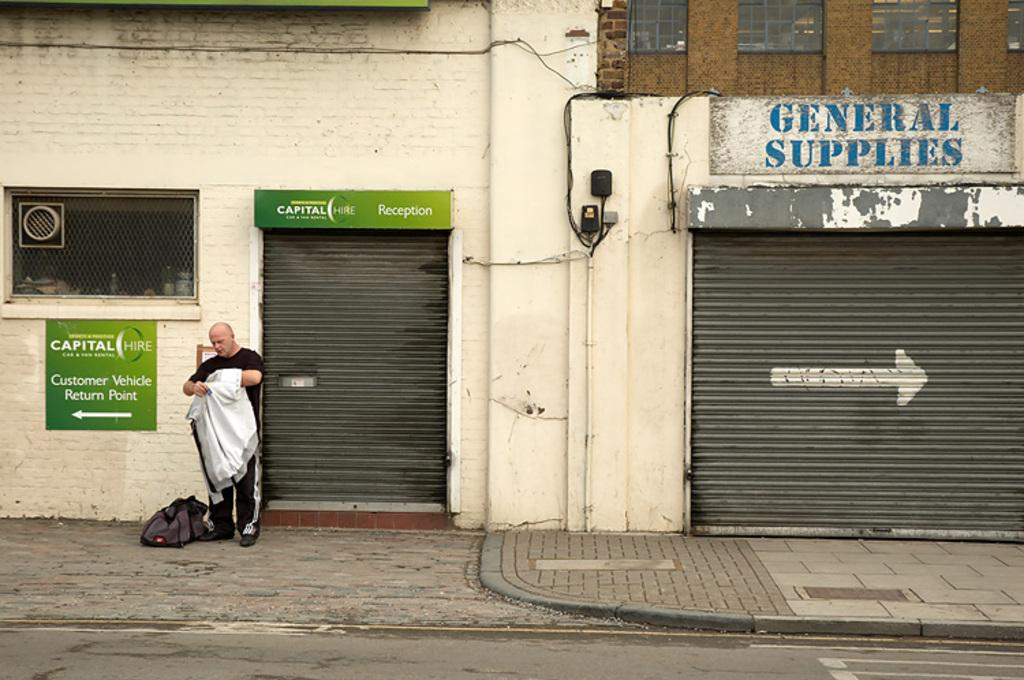What is the man in the image doing? The man is standing in the image and holding an item. What else can be seen in the image besides the man? There is a bag, boards, shutters, and a road visible in the image. What do these elements suggest about the location? These elements suggest the presence of buildings. What thrilling fact can be learned about the ball in the image? There is no ball present in the image, so no thrilling facts about a ball can be learned. 